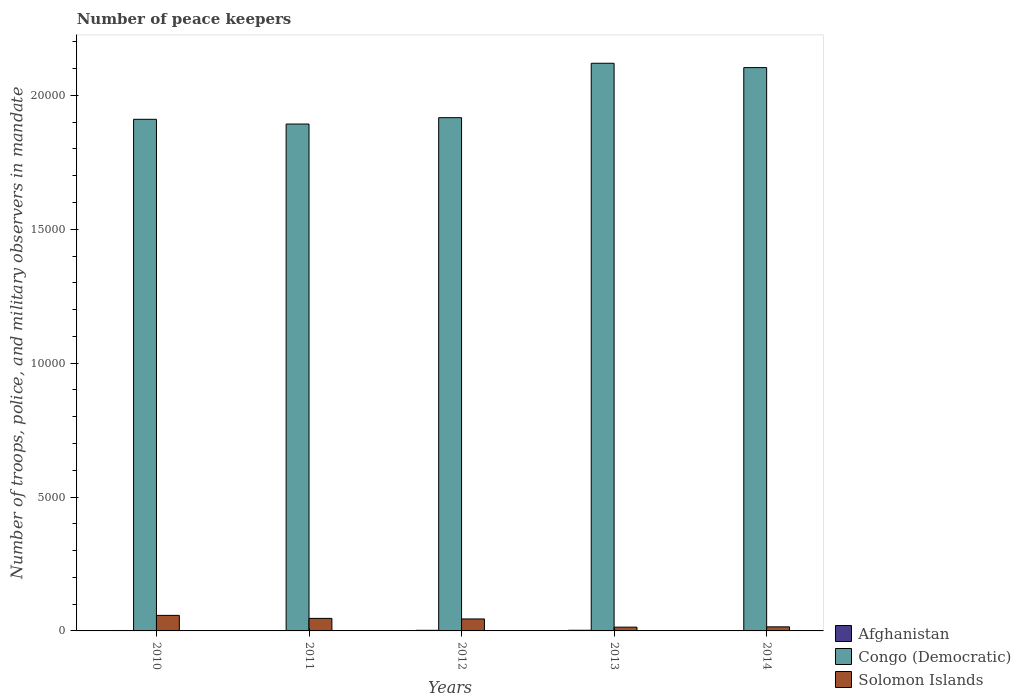How many different coloured bars are there?
Give a very brief answer. 3. Are the number of bars on each tick of the X-axis equal?
Ensure brevity in your answer.  Yes. How many bars are there on the 4th tick from the left?
Make the answer very short. 3. How many bars are there on the 3rd tick from the right?
Give a very brief answer. 3. What is the label of the 4th group of bars from the left?
Keep it short and to the point. 2013. What is the number of peace keepers in in Afghanistan in 2014?
Make the answer very short. 15. Across all years, what is the maximum number of peace keepers in in Congo (Democratic)?
Your response must be concise. 2.12e+04. Across all years, what is the minimum number of peace keepers in in Afghanistan?
Offer a terse response. 15. In which year was the number of peace keepers in in Congo (Democratic) maximum?
Your response must be concise. 2013. In which year was the number of peace keepers in in Congo (Democratic) minimum?
Offer a very short reply. 2011. What is the total number of peace keepers in in Solomon Islands in the graph?
Provide a short and direct response. 1788. What is the difference between the number of peace keepers in in Solomon Islands in 2013 and that in 2014?
Provide a short and direct response. -11. What is the difference between the number of peace keepers in in Afghanistan in 2011 and the number of peace keepers in in Solomon Islands in 2013?
Offer a terse response. -126. What is the average number of peace keepers in in Solomon Islands per year?
Offer a very short reply. 357.6. In the year 2012, what is the difference between the number of peace keepers in in Congo (Democratic) and number of peace keepers in in Afghanistan?
Provide a succinct answer. 1.91e+04. What is the difference between the highest and the second highest number of peace keepers in in Solomon Islands?
Your answer should be very brief. 112. What is the difference between the highest and the lowest number of peace keepers in in Congo (Democratic)?
Make the answer very short. 2270. In how many years, is the number of peace keepers in in Afghanistan greater than the average number of peace keepers in in Afghanistan taken over all years?
Your answer should be very brief. 2. What does the 1st bar from the left in 2010 represents?
Make the answer very short. Afghanistan. What does the 2nd bar from the right in 2013 represents?
Provide a short and direct response. Congo (Democratic). How many bars are there?
Make the answer very short. 15. How many years are there in the graph?
Give a very brief answer. 5. Where does the legend appear in the graph?
Offer a very short reply. Bottom right. How many legend labels are there?
Make the answer very short. 3. What is the title of the graph?
Your response must be concise. Number of peace keepers. Does "Palau" appear as one of the legend labels in the graph?
Give a very brief answer. No. What is the label or title of the Y-axis?
Ensure brevity in your answer.  Number of troops, police, and military observers in mandate. What is the Number of troops, police, and military observers in mandate of Congo (Democratic) in 2010?
Your answer should be very brief. 1.91e+04. What is the Number of troops, police, and military observers in mandate of Solomon Islands in 2010?
Keep it short and to the point. 580. What is the Number of troops, police, and military observers in mandate of Congo (Democratic) in 2011?
Keep it short and to the point. 1.89e+04. What is the Number of troops, police, and military observers in mandate in Solomon Islands in 2011?
Ensure brevity in your answer.  468. What is the Number of troops, police, and military observers in mandate in Afghanistan in 2012?
Your answer should be compact. 23. What is the Number of troops, police, and military observers in mandate of Congo (Democratic) in 2012?
Give a very brief answer. 1.92e+04. What is the Number of troops, police, and military observers in mandate of Solomon Islands in 2012?
Your answer should be very brief. 447. What is the Number of troops, police, and military observers in mandate of Congo (Democratic) in 2013?
Give a very brief answer. 2.12e+04. What is the Number of troops, police, and military observers in mandate in Solomon Islands in 2013?
Give a very brief answer. 141. What is the Number of troops, police, and military observers in mandate in Afghanistan in 2014?
Keep it short and to the point. 15. What is the Number of troops, police, and military observers in mandate in Congo (Democratic) in 2014?
Your response must be concise. 2.10e+04. What is the Number of troops, police, and military observers in mandate of Solomon Islands in 2014?
Keep it short and to the point. 152. Across all years, what is the maximum Number of troops, police, and military observers in mandate of Afghanistan?
Provide a succinct answer. 25. Across all years, what is the maximum Number of troops, police, and military observers in mandate in Congo (Democratic)?
Make the answer very short. 2.12e+04. Across all years, what is the maximum Number of troops, police, and military observers in mandate of Solomon Islands?
Your response must be concise. 580. Across all years, what is the minimum Number of troops, police, and military observers in mandate in Afghanistan?
Keep it short and to the point. 15. Across all years, what is the minimum Number of troops, police, and military observers in mandate of Congo (Democratic)?
Offer a terse response. 1.89e+04. Across all years, what is the minimum Number of troops, police, and military observers in mandate in Solomon Islands?
Ensure brevity in your answer.  141. What is the total Number of troops, police, and military observers in mandate in Afghanistan in the graph?
Your response must be concise. 94. What is the total Number of troops, police, and military observers in mandate in Congo (Democratic) in the graph?
Your answer should be very brief. 9.94e+04. What is the total Number of troops, police, and military observers in mandate of Solomon Islands in the graph?
Make the answer very short. 1788. What is the difference between the Number of troops, police, and military observers in mandate in Congo (Democratic) in 2010 and that in 2011?
Keep it short and to the point. 177. What is the difference between the Number of troops, police, and military observers in mandate in Solomon Islands in 2010 and that in 2011?
Offer a terse response. 112. What is the difference between the Number of troops, police, and military observers in mandate in Congo (Democratic) in 2010 and that in 2012?
Your answer should be very brief. -61. What is the difference between the Number of troops, police, and military observers in mandate of Solomon Islands in 2010 and that in 2012?
Your response must be concise. 133. What is the difference between the Number of troops, police, and military observers in mandate in Congo (Democratic) in 2010 and that in 2013?
Ensure brevity in your answer.  -2093. What is the difference between the Number of troops, police, and military observers in mandate in Solomon Islands in 2010 and that in 2013?
Provide a succinct answer. 439. What is the difference between the Number of troops, police, and military observers in mandate of Congo (Democratic) in 2010 and that in 2014?
Ensure brevity in your answer.  -1931. What is the difference between the Number of troops, police, and military observers in mandate of Solomon Islands in 2010 and that in 2014?
Offer a terse response. 428. What is the difference between the Number of troops, police, and military observers in mandate of Afghanistan in 2011 and that in 2012?
Ensure brevity in your answer.  -8. What is the difference between the Number of troops, police, and military observers in mandate of Congo (Democratic) in 2011 and that in 2012?
Provide a succinct answer. -238. What is the difference between the Number of troops, police, and military observers in mandate in Afghanistan in 2011 and that in 2013?
Keep it short and to the point. -10. What is the difference between the Number of troops, police, and military observers in mandate in Congo (Democratic) in 2011 and that in 2013?
Keep it short and to the point. -2270. What is the difference between the Number of troops, police, and military observers in mandate of Solomon Islands in 2011 and that in 2013?
Ensure brevity in your answer.  327. What is the difference between the Number of troops, police, and military observers in mandate in Afghanistan in 2011 and that in 2014?
Your answer should be very brief. 0. What is the difference between the Number of troops, police, and military observers in mandate of Congo (Democratic) in 2011 and that in 2014?
Your response must be concise. -2108. What is the difference between the Number of troops, police, and military observers in mandate of Solomon Islands in 2011 and that in 2014?
Your answer should be very brief. 316. What is the difference between the Number of troops, police, and military observers in mandate of Afghanistan in 2012 and that in 2013?
Your response must be concise. -2. What is the difference between the Number of troops, police, and military observers in mandate in Congo (Democratic) in 2012 and that in 2013?
Your response must be concise. -2032. What is the difference between the Number of troops, police, and military observers in mandate of Solomon Islands in 2012 and that in 2013?
Your response must be concise. 306. What is the difference between the Number of troops, police, and military observers in mandate of Congo (Democratic) in 2012 and that in 2014?
Make the answer very short. -1870. What is the difference between the Number of troops, police, and military observers in mandate of Solomon Islands in 2012 and that in 2014?
Your answer should be compact. 295. What is the difference between the Number of troops, police, and military observers in mandate of Congo (Democratic) in 2013 and that in 2014?
Keep it short and to the point. 162. What is the difference between the Number of troops, police, and military observers in mandate of Solomon Islands in 2013 and that in 2014?
Keep it short and to the point. -11. What is the difference between the Number of troops, police, and military observers in mandate in Afghanistan in 2010 and the Number of troops, police, and military observers in mandate in Congo (Democratic) in 2011?
Make the answer very short. -1.89e+04. What is the difference between the Number of troops, police, and military observers in mandate in Afghanistan in 2010 and the Number of troops, police, and military observers in mandate in Solomon Islands in 2011?
Ensure brevity in your answer.  -452. What is the difference between the Number of troops, police, and military observers in mandate of Congo (Democratic) in 2010 and the Number of troops, police, and military observers in mandate of Solomon Islands in 2011?
Provide a short and direct response. 1.86e+04. What is the difference between the Number of troops, police, and military observers in mandate in Afghanistan in 2010 and the Number of troops, police, and military observers in mandate in Congo (Democratic) in 2012?
Your answer should be compact. -1.92e+04. What is the difference between the Number of troops, police, and military observers in mandate of Afghanistan in 2010 and the Number of troops, police, and military observers in mandate of Solomon Islands in 2012?
Make the answer very short. -431. What is the difference between the Number of troops, police, and military observers in mandate of Congo (Democratic) in 2010 and the Number of troops, police, and military observers in mandate of Solomon Islands in 2012?
Keep it short and to the point. 1.87e+04. What is the difference between the Number of troops, police, and military observers in mandate in Afghanistan in 2010 and the Number of troops, police, and military observers in mandate in Congo (Democratic) in 2013?
Provide a succinct answer. -2.12e+04. What is the difference between the Number of troops, police, and military observers in mandate in Afghanistan in 2010 and the Number of troops, police, and military observers in mandate in Solomon Islands in 2013?
Offer a terse response. -125. What is the difference between the Number of troops, police, and military observers in mandate of Congo (Democratic) in 2010 and the Number of troops, police, and military observers in mandate of Solomon Islands in 2013?
Ensure brevity in your answer.  1.90e+04. What is the difference between the Number of troops, police, and military observers in mandate in Afghanistan in 2010 and the Number of troops, police, and military observers in mandate in Congo (Democratic) in 2014?
Your answer should be compact. -2.10e+04. What is the difference between the Number of troops, police, and military observers in mandate of Afghanistan in 2010 and the Number of troops, police, and military observers in mandate of Solomon Islands in 2014?
Provide a short and direct response. -136. What is the difference between the Number of troops, police, and military observers in mandate of Congo (Democratic) in 2010 and the Number of troops, police, and military observers in mandate of Solomon Islands in 2014?
Your answer should be very brief. 1.90e+04. What is the difference between the Number of troops, police, and military observers in mandate of Afghanistan in 2011 and the Number of troops, police, and military observers in mandate of Congo (Democratic) in 2012?
Offer a terse response. -1.92e+04. What is the difference between the Number of troops, police, and military observers in mandate of Afghanistan in 2011 and the Number of troops, police, and military observers in mandate of Solomon Islands in 2012?
Your answer should be compact. -432. What is the difference between the Number of troops, police, and military observers in mandate in Congo (Democratic) in 2011 and the Number of troops, police, and military observers in mandate in Solomon Islands in 2012?
Your answer should be compact. 1.85e+04. What is the difference between the Number of troops, police, and military observers in mandate in Afghanistan in 2011 and the Number of troops, police, and military observers in mandate in Congo (Democratic) in 2013?
Your response must be concise. -2.12e+04. What is the difference between the Number of troops, police, and military observers in mandate of Afghanistan in 2011 and the Number of troops, police, and military observers in mandate of Solomon Islands in 2013?
Ensure brevity in your answer.  -126. What is the difference between the Number of troops, police, and military observers in mandate of Congo (Democratic) in 2011 and the Number of troops, police, and military observers in mandate of Solomon Islands in 2013?
Make the answer very short. 1.88e+04. What is the difference between the Number of troops, police, and military observers in mandate in Afghanistan in 2011 and the Number of troops, police, and military observers in mandate in Congo (Democratic) in 2014?
Your response must be concise. -2.10e+04. What is the difference between the Number of troops, police, and military observers in mandate in Afghanistan in 2011 and the Number of troops, police, and military observers in mandate in Solomon Islands in 2014?
Your response must be concise. -137. What is the difference between the Number of troops, police, and military observers in mandate in Congo (Democratic) in 2011 and the Number of troops, police, and military observers in mandate in Solomon Islands in 2014?
Offer a very short reply. 1.88e+04. What is the difference between the Number of troops, police, and military observers in mandate of Afghanistan in 2012 and the Number of troops, police, and military observers in mandate of Congo (Democratic) in 2013?
Your response must be concise. -2.12e+04. What is the difference between the Number of troops, police, and military observers in mandate of Afghanistan in 2012 and the Number of troops, police, and military observers in mandate of Solomon Islands in 2013?
Your answer should be compact. -118. What is the difference between the Number of troops, police, and military observers in mandate of Congo (Democratic) in 2012 and the Number of troops, police, and military observers in mandate of Solomon Islands in 2013?
Give a very brief answer. 1.90e+04. What is the difference between the Number of troops, police, and military observers in mandate in Afghanistan in 2012 and the Number of troops, police, and military observers in mandate in Congo (Democratic) in 2014?
Your response must be concise. -2.10e+04. What is the difference between the Number of troops, police, and military observers in mandate of Afghanistan in 2012 and the Number of troops, police, and military observers in mandate of Solomon Islands in 2014?
Your response must be concise. -129. What is the difference between the Number of troops, police, and military observers in mandate in Congo (Democratic) in 2012 and the Number of troops, police, and military observers in mandate in Solomon Islands in 2014?
Your answer should be compact. 1.90e+04. What is the difference between the Number of troops, police, and military observers in mandate of Afghanistan in 2013 and the Number of troops, police, and military observers in mandate of Congo (Democratic) in 2014?
Make the answer very short. -2.10e+04. What is the difference between the Number of troops, police, and military observers in mandate in Afghanistan in 2013 and the Number of troops, police, and military observers in mandate in Solomon Islands in 2014?
Keep it short and to the point. -127. What is the difference between the Number of troops, police, and military observers in mandate in Congo (Democratic) in 2013 and the Number of troops, police, and military observers in mandate in Solomon Islands in 2014?
Make the answer very short. 2.10e+04. What is the average Number of troops, police, and military observers in mandate in Congo (Democratic) per year?
Ensure brevity in your answer.  1.99e+04. What is the average Number of troops, police, and military observers in mandate in Solomon Islands per year?
Your answer should be very brief. 357.6. In the year 2010, what is the difference between the Number of troops, police, and military observers in mandate in Afghanistan and Number of troops, police, and military observers in mandate in Congo (Democratic)?
Provide a short and direct response. -1.91e+04. In the year 2010, what is the difference between the Number of troops, police, and military observers in mandate of Afghanistan and Number of troops, police, and military observers in mandate of Solomon Islands?
Provide a succinct answer. -564. In the year 2010, what is the difference between the Number of troops, police, and military observers in mandate in Congo (Democratic) and Number of troops, police, and military observers in mandate in Solomon Islands?
Make the answer very short. 1.85e+04. In the year 2011, what is the difference between the Number of troops, police, and military observers in mandate in Afghanistan and Number of troops, police, and military observers in mandate in Congo (Democratic)?
Your response must be concise. -1.89e+04. In the year 2011, what is the difference between the Number of troops, police, and military observers in mandate in Afghanistan and Number of troops, police, and military observers in mandate in Solomon Islands?
Give a very brief answer. -453. In the year 2011, what is the difference between the Number of troops, police, and military observers in mandate in Congo (Democratic) and Number of troops, police, and military observers in mandate in Solomon Islands?
Provide a succinct answer. 1.85e+04. In the year 2012, what is the difference between the Number of troops, police, and military observers in mandate of Afghanistan and Number of troops, police, and military observers in mandate of Congo (Democratic)?
Offer a terse response. -1.91e+04. In the year 2012, what is the difference between the Number of troops, police, and military observers in mandate of Afghanistan and Number of troops, police, and military observers in mandate of Solomon Islands?
Offer a terse response. -424. In the year 2012, what is the difference between the Number of troops, police, and military observers in mandate of Congo (Democratic) and Number of troops, police, and military observers in mandate of Solomon Islands?
Ensure brevity in your answer.  1.87e+04. In the year 2013, what is the difference between the Number of troops, police, and military observers in mandate of Afghanistan and Number of troops, police, and military observers in mandate of Congo (Democratic)?
Give a very brief answer. -2.12e+04. In the year 2013, what is the difference between the Number of troops, police, and military observers in mandate of Afghanistan and Number of troops, police, and military observers in mandate of Solomon Islands?
Keep it short and to the point. -116. In the year 2013, what is the difference between the Number of troops, police, and military observers in mandate in Congo (Democratic) and Number of troops, police, and military observers in mandate in Solomon Islands?
Your answer should be very brief. 2.11e+04. In the year 2014, what is the difference between the Number of troops, police, and military observers in mandate in Afghanistan and Number of troops, police, and military observers in mandate in Congo (Democratic)?
Offer a terse response. -2.10e+04. In the year 2014, what is the difference between the Number of troops, police, and military observers in mandate of Afghanistan and Number of troops, police, and military observers in mandate of Solomon Islands?
Keep it short and to the point. -137. In the year 2014, what is the difference between the Number of troops, police, and military observers in mandate in Congo (Democratic) and Number of troops, police, and military observers in mandate in Solomon Islands?
Ensure brevity in your answer.  2.09e+04. What is the ratio of the Number of troops, police, and military observers in mandate of Afghanistan in 2010 to that in 2011?
Offer a very short reply. 1.07. What is the ratio of the Number of troops, police, and military observers in mandate of Congo (Democratic) in 2010 to that in 2011?
Your answer should be compact. 1.01. What is the ratio of the Number of troops, police, and military observers in mandate of Solomon Islands in 2010 to that in 2011?
Give a very brief answer. 1.24. What is the ratio of the Number of troops, police, and military observers in mandate in Afghanistan in 2010 to that in 2012?
Offer a terse response. 0.7. What is the ratio of the Number of troops, police, and military observers in mandate in Solomon Islands in 2010 to that in 2012?
Your answer should be very brief. 1.3. What is the ratio of the Number of troops, police, and military observers in mandate of Afghanistan in 2010 to that in 2013?
Give a very brief answer. 0.64. What is the ratio of the Number of troops, police, and military observers in mandate in Congo (Democratic) in 2010 to that in 2013?
Offer a very short reply. 0.9. What is the ratio of the Number of troops, police, and military observers in mandate in Solomon Islands in 2010 to that in 2013?
Provide a succinct answer. 4.11. What is the ratio of the Number of troops, police, and military observers in mandate of Afghanistan in 2010 to that in 2014?
Your response must be concise. 1.07. What is the ratio of the Number of troops, police, and military observers in mandate in Congo (Democratic) in 2010 to that in 2014?
Offer a terse response. 0.91. What is the ratio of the Number of troops, police, and military observers in mandate in Solomon Islands in 2010 to that in 2014?
Provide a succinct answer. 3.82. What is the ratio of the Number of troops, police, and military observers in mandate of Afghanistan in 2011 to that in 2012?
Offer a very short reply. 0.65. What is the ratio of the Number of troops, police, and military observers in mandate in Congo (Democratic) in 2011 to that in 2012?
Provide a succinct answer. 0.99. What is the ratio of the Number of troops, police, and military observers in mandate in Solomon Islands in 2011 to that in 2012?
Your response must be concise. 1.05. What is the ratio of the Number of troops, police, and military observers in mandate of Congo (Democratic) in 2011 to that in 2013?
Ensure brevity in your answer.  0.89. What is the ratio of the Number of troops, police, and military observers in mandate of Solomon Islands in 2011 to that in 2013?
Offer a terse response. 3.32. What is the ratio of the Number of troops, police, and military observers in mandate in Congo (Democratic) in 2011 to that in 2014?
Keep it short and to the point. 0.9. What is the ratio of the Number of troops, police, and military observers in mandate in Solomon Islands in 2011 to that in 2014?
Keep it short and to the point. 3.08. What is the ratio of the Number of troops, police, and military observers in mandate of Congo (Democratic) in 2012 to that in 2013?
Offer a very short reply. 0.9. What is the ratio of the Number of troops, police, and military observers in mandate of Solomon Islands in 2012 to that in 2013?
Ensure brevity in your answer.  3.17. What is the ratio of the Number of troops, police, and military observers in mandate in Afghanistan in 2012 to that in 2014?
Offer a terse response. 1.53. What is the ratio of the Number of troops, police, and military observers in mandate in Congo (Democratic) in 2012 to that in 2014?
Your answer should be compact. 0.91. What is the ratio of the Number of troops, police, and military observers in mandate of Solomon Islands in 2012 to that in 2014?
Give a very brief answer. 2.94. What is the ratio of the Number of troops, police, and military observers in mandate of Afghanistan in 2013 to that in 2014?
Your answer should be very brief. 1.67. What is the ratio of the Number of troops, police, and military observers in mandate of Congo (Democratic) in 2013 to that in 2014?
Your response must be concise. 1.01. What is the ratio of the Number of troops, police, and military observers in mandate in Solomon Islands in 2013 to that in 2014?
Give a very brief answer. 0.93. What is the difference between the highest and the second highest Number of troops, police, and military observers in mandate in Afghanistan?
Provide a succinct answer. 2. What is the difference between the highest and the second highest Number of troops, police, and military observers in mandate of Congo (Democratic)?
Provide a succinct answer. 162. What is the difference between the highest and the second highest Number of troops, police, and military observers in mandate in Solomon Islands?
Ensure brevity in your answer.  112. What is the difference between the highest and the lowest Number of troops, police, and military observers in mandate in Congo (Democratic)?
Give a very brief answer. 2270. What is the difference between the highest and the lowest Number of troops, police, and military observers in mandate in Solomon Islands?
Make the answer very short. 439. 